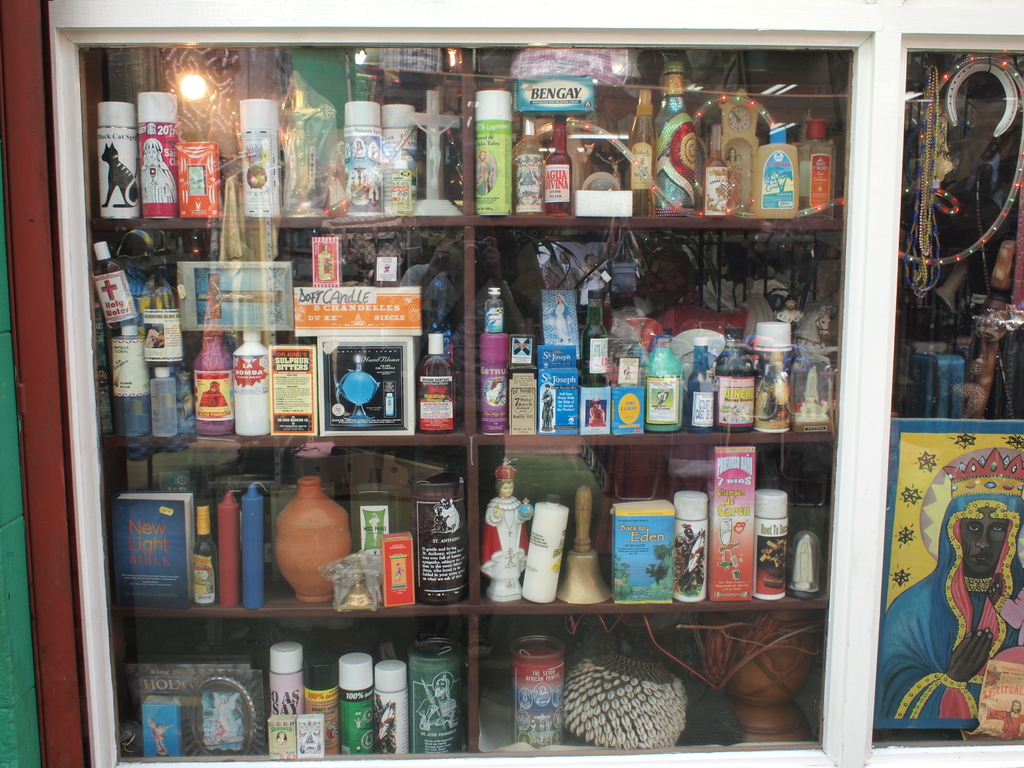What can you infer about the store owner's intentions based on the variety of items? The store owner likely aims to cater to a diverse customer base, possibly interested in a range of spiritual, holistic, and traditional practices. The assortment of items from different cultures and belief systems suggests an inclusive approach, probably intending to serve as a one-stop shop for individuals seeking comfort, healing, and heritage through various artifacts.  What era do you think most of these items come from, given their designs and packaging? Many of these items appear to have a vintage or retro aesthetic, suggesting they might be from the mid to late 20th century. The packaging of some products, like the traditional remedies and old-style label designs, reinforce this time frame, reflecting a nostalgic appeal that might resonate with collectors or those appreciative of yesteryear's aesthetics. 